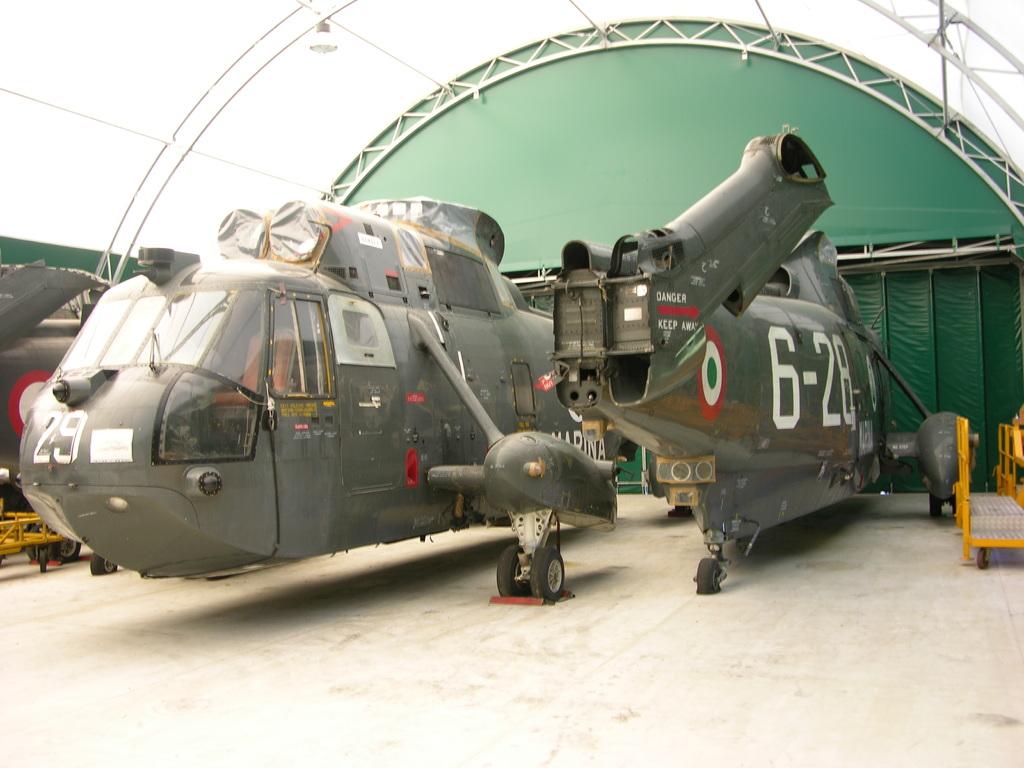What number is on the nose cone?
Your answer should be very brief. 29. 